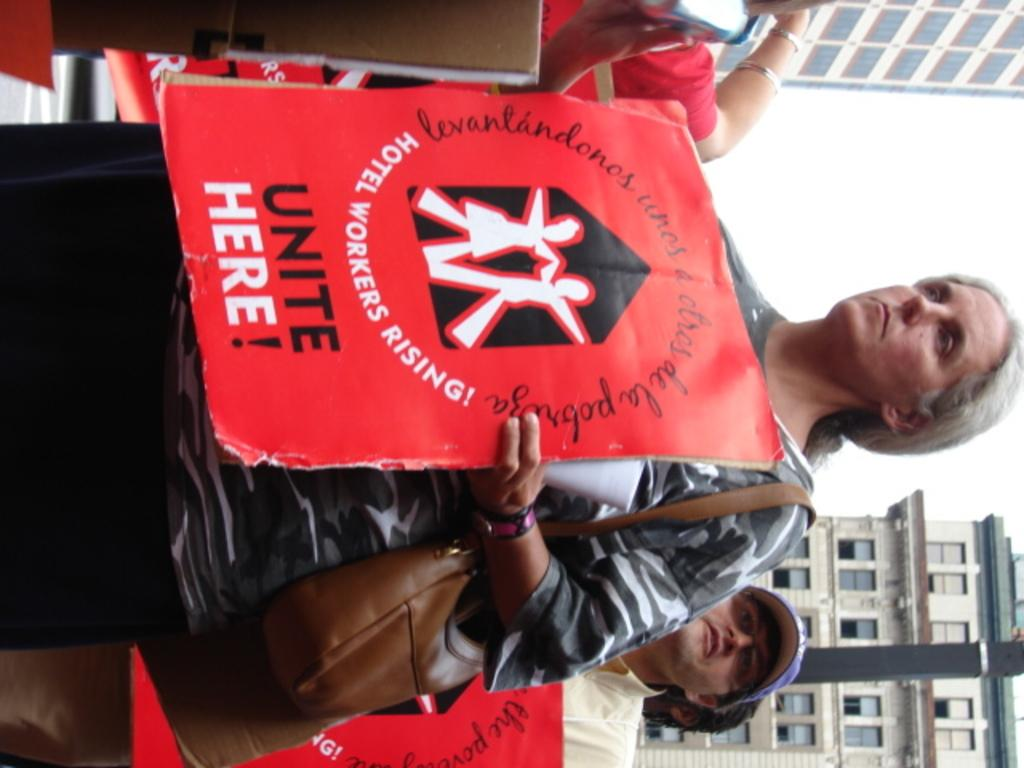How many people are in the image? There are persons in the image, but the exact number is not specified. What are the persons holding in the image? The persons are holding boards in the image. What can be seen at the bottom of the image? There are buildings at the bottom of the image. What can be seen at the top of the image? There are buildings at the top of the image. How many kittens are sitting on the structure in the image? There are no kittens present in the image, and no structure is mentioned in the facts provided. 